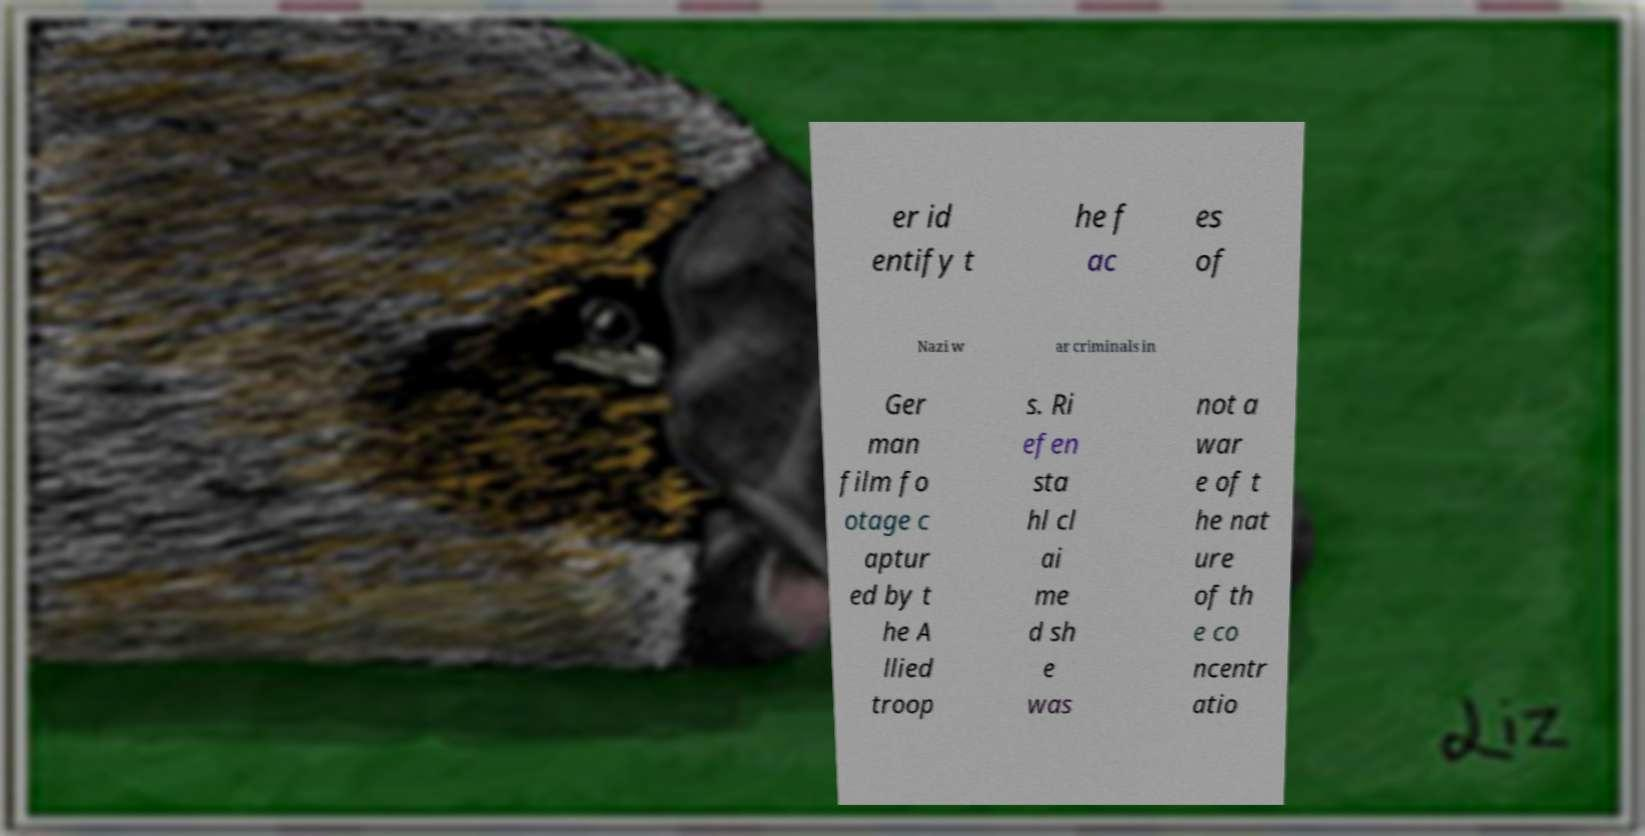Can you read and provide the text displayed in the image?This photo seems to have some interesting text. Can you extract and type it out for me? er id entify t he f ac es of Nazi w ar criminals in Ger man film fo otage c aptur ed by t he A llied troop s. Ri efen sta hl cl ai me d sh e was not a war e of t he nat ure of th e co ncentr atio 